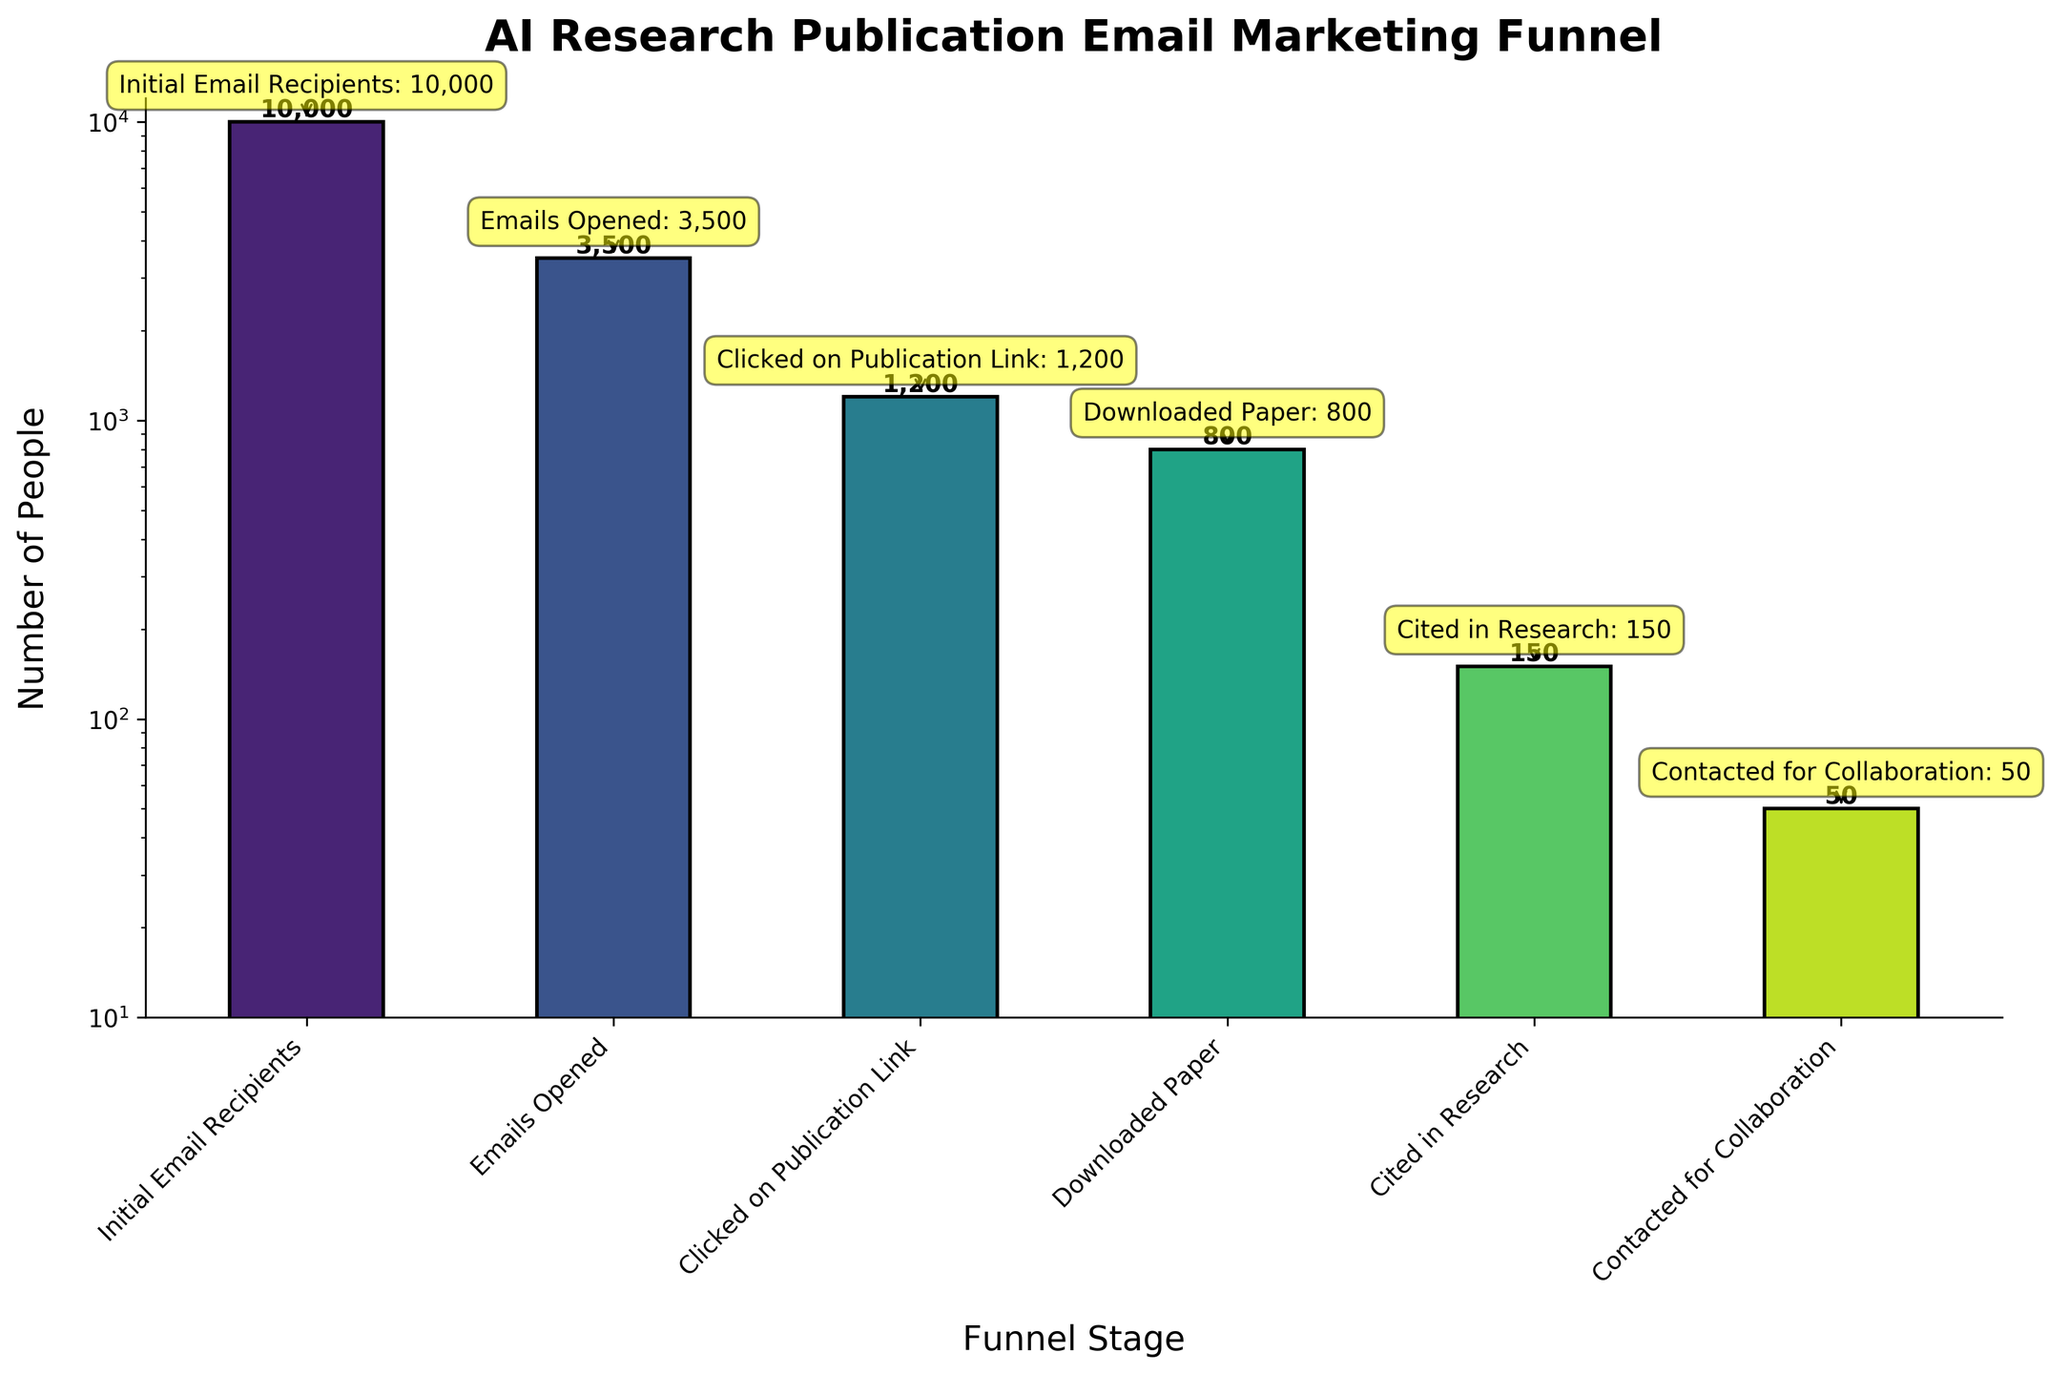What's the title of the funnel chart? The title is located at the top part of the figure and describes the main topic of the visual representation. The title reads "AI Research Publication Email Marketing Funnel".
Answer: AI Research Publication Email Marketing Funnel What stage has the highest count? The stage with the highest count can be observed as the tallest bar in the chart. The bar labeled "Initial Email Recipients" has a count of 10,000, which is the highest value.
Answer: Initial Email Recipients What is the count of people who cited the research? To find the count of people who cited the research, look at the bar labeled "Cited in Research" and the number displayed at the top of this bar. The count is 150.
Answer: 150 How many stages are there in the funnel? The number of stages corresponds to the number of distinct bars in the chart. Each bar represents a different stage. Counting the bars, there are 6 stages.
Answer: 6 What is the difference between the number of 'Emails Opened' and 'Downloaded Paper'? Find the counts of 'Emails Opened' and 'Downloaded Paper' and subtract the latter from the former. 'Emails Opened' is 3,500 and 'Downloaded Paper' is 800, so 3,500 - 800 = 2,700.
Answer: 2,700 Which stage has the smallest count? The stage with the smallest count is the shortest bar in the chart. The bar labeled "Contacted for Collaboration" has the smallest count of 50.
Answer: Contacted for Collaboration What percentage of the 'Emails Opened' led to 'Downloaded Paper'? Calculate the proportion of 'Downloaded Paper' to 'Emails Opened' and multiply by 100. The count for 'Downloaded Paper' is 800 and 'Emails Opened' is 3,500. So (800 / 3,500) * 100 = 22.86%.
Answer: 22.86% What is the ratio of 'Initial Email Recipients' to 'Clicked on Publication Link'? Divide the count of 'Initial Email Recipients' by the count of 'Clicked on Publication Link'. The count for 'Initial Email Recipients' is 10,000 and for 'Clicked on Publication Link' is 1,200. So, the ratio is 10,000 / 1,200 ≈ 8.33.
Answer: 8.33 Is the count of 'Cited in Research' greater than the count of 'Contacted for Collaboration'? Compare the counts of 'Cited in Research' (150) and 'Contacted for Collaboration' (50). Since 150 is greater than 50, the answer is yes.
Answer: Yes How does the count of 'Downloaded Paper' compare to 'Emails Opened'? Compare the counts of 'Downloaded Paper' (800) and 'Emails Opened' (3,500). Since 800 is less than 3,500, the count of 'Downloaded Paper' is significantly lower.
Answer: Less 